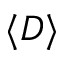<formula> <loc_0><loc_0><loc_500><loc_500>\langle D \rangle</formula> 